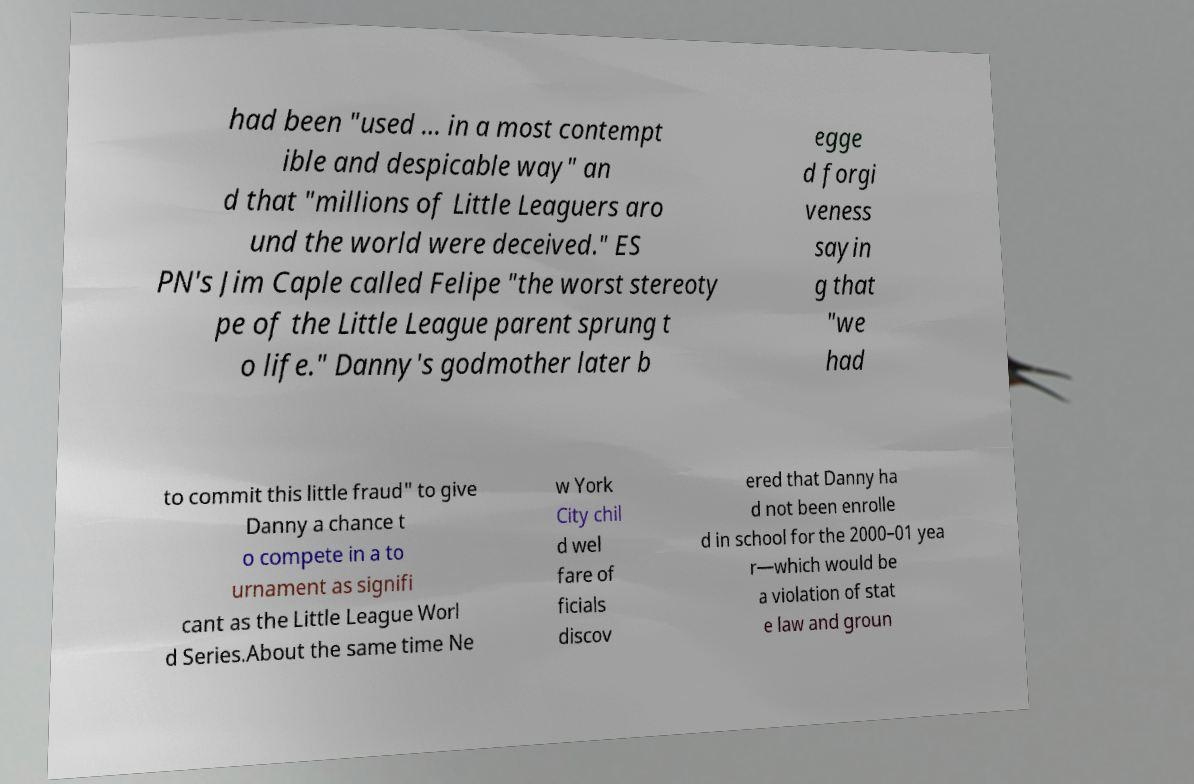For documentation purposes, I need the text within this image transcribed. Could you provide that? had been "used ... in a most contempt ible and despicable way" an d that "millions of Little Leaguers aro und the world were deceived." ES PN's Jim Caple called Felipe "the worst stereoty pe of the Little League parent sprung t o life." Danny's godmother later b egge d forgi veness sayin g that "we had to commit this little fraud" to give Danny a chance t o compete in a to urnament as signifi cant as the Little League Worl d Series.About the same time Ne w York City chil d wel fare of ficials discov ered that Danny ha d not been enrolle d in school for the 2000–01 yea r—which would be a violation of stat e law and groun 